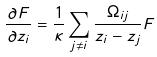Convert formula to latex. <formula><loc_0><loc_0><loc_500><loc_500>\frac { \partial F } { \partial z _ { i } } = \frac { 1 } { \kappa } \sum _ { j \neq i } \frac { \Omega _ { i j } } { z _ { i } - z _ { j } } F</formula> 